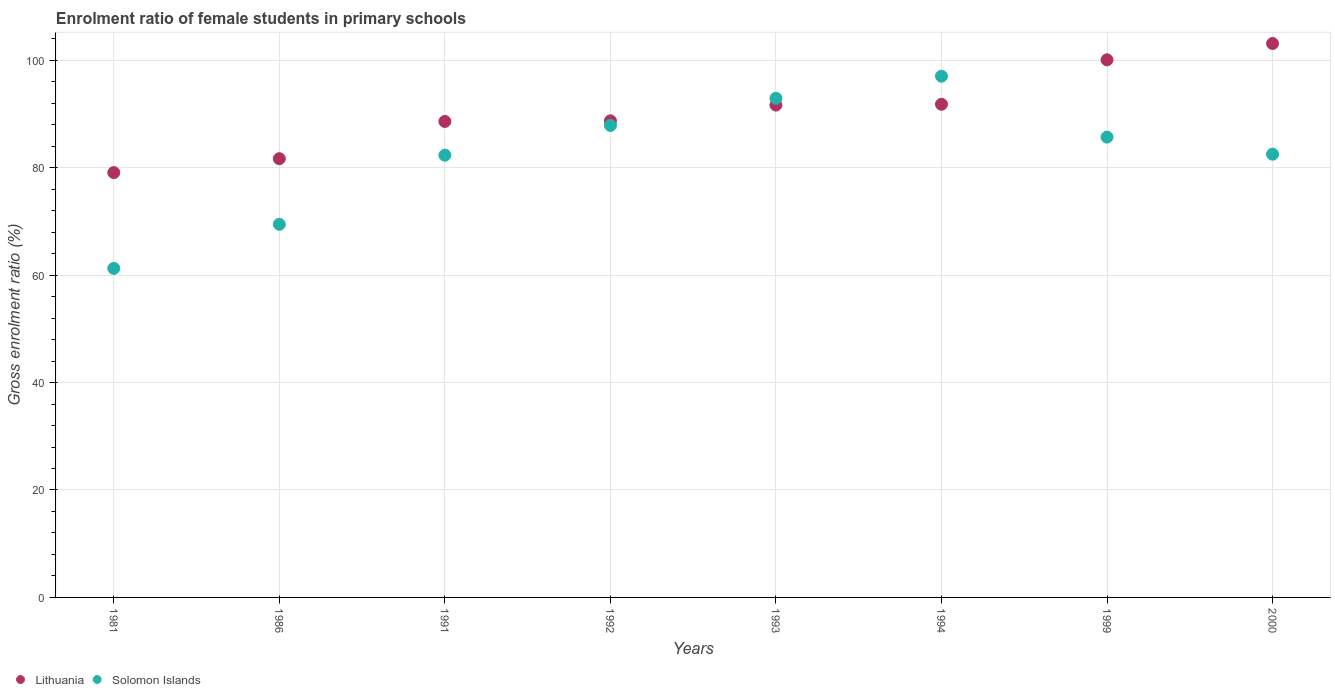Is the number of dotlines equal to the number of legend labels?
Offer a terse response. Yes. What is the enrolment ratio of female students in primary schools in Lithuania in 1991?
Provide a succinct answer. 88.6. Across all years, what is the maximum enrolment ratio of female students in primary schools in Lithuania?
Give a very brief answer. 103.11. Across all years, what is the minimum enrolment ratio of female students in primary schools in Lithuania?
Provide a short and direct response. 79.08. In which year was the enrolment ratio of female students in primary schools in Lithuania maximum?
Ensure brevity in your answer.  2000. In which year was the enrolment ratio of female students in primary schools in Solomon Islands minimum?
Ensure brevity in your answer.  1981. What is the total enrolment ratio of female students in primary schools in Solomon Islands in the graph?
Make the answer very short. 659.01. What is the difference between the enrolment ratio of female students in primary schools in Solomon Islands in 1991 and that in 1994?
Make the answer very short. -14.71. What is the difference between the enrolment ratio of female students in primary schools in Lithuania in 1981 and the enrolment ratio of female students in primary schools in Solomon Islands in 2000?
Offer a very short reply. -3.43. What is the average enrolment ratio of female students in primary schools in Lithuania per year?
Your answer should be very brief. 90.59. In the year 1994, what is the difference between the enrolment ratio of female students in primary schools in Solomon Islands and enrolment ratio of female students in primary schools in Lithuania?
Offer a terse response. 5.23. What is the ratio of the enrolment ratio of female students in primary schools in Solomon Islands in 1991 to that in 2000?
Offer a very short reply. 1. Is the enrolment ratio of female students in primary schools in Solomon Islands in 1986 less than that in 2000?
Provide a short and direct response. Yes. What is the difference between the highest and the second highest enrolment ratio of female students in primary schools in Lithuania?
Provide a succinct answer. 3.04. What is the difference between the highest and the lowest enrolment ratio of female students in primary schools in Lithuania?
Your answer should be compact. 24.03. Does the enrolment ratio of female students in primary schools in Solomon Islands monotonically increase over the years?
Provide a short and direct response. No. How many dotlines are there?
Your answer should be very brief. 2. How many years are there in the graph?
Give a very brief answer. 8. What is the difference between two consecutive major ticks on the Y-axis?
Provide a succinct answer. 20. Does the graph contain any zero values?
Make the answer very short. No. Where does the legend appear in the graph?
Ensure brevity in your answer.  Bottom left. What is the title of the graph?
Offer a very short reply. Enrolment ratio of female students in primary schools. Does "Other small states" appear as one of the legend labels in the graph?
Ensure brevity in your answer.  No. What is the label or title of the X-axis?
Ensure brevity in your answer.  Years. What is the Gross enrolment ratio (%) of Lithuania in 1981?
Make the answer very short. 79.08. What is the Gross enrolment ratio (%) of Solomon Islands in 1981?
Provide a short and direct response. 61.25. What is the Gross enrolment ratio (%) of Lithuania in 1986?
Offer a terse response. 81.67. What is the Gross enrolment ratio (%) in Solomon Islands in 1986?
Offer a very short reply. 69.45. What is the Gross enrolment ratio (%) of Lithuania in 1991?
Offer a terse response. 88.6. What is the Gross enrolment ratio (%) of Solomon Islands in 1991?
Offer a very short reply. 82.32. What is the Gross enrolment ratio (%) in Lithuania in 1992?
Offer a terse response. 88.71. What is the Gross enrolment ratio (%) of Solomon Islands in 1992?
Your answer should be very brief. 87.85. What is the Gross enrolment ratio (%) in Lithuania in 1993?
Provide a succinct answer. 91.65. What is the Gross enrolment ratio (%) in Solomon Islands in 1993?
Offer a very short reply. 92.91. What is the Gross enrolment ratio (%) in Lithuania in 1994?
Your answer should be very brief. 91.8. What is the Gross enrolment ratio (%) in Solomon Islands in 1994?
Offer a terse response. 97.03. What is the Gross enrolment ratio (%) of Lithuania in 1999?
Give a very brief answer. 100.08. What is the Gross enrolment ratio (%) in Solomon Islands in 1999?
Provide a succinct answer. 85.69. What is the Gross enrolment ratio (%) of Lithuania in 2000?
Your answer should be compact. 103.11. What is the Gross enrolment ratio (%) of Solomon Islands in 2000?
Your response must be concise. 82.51. Across all years, what is the maximum Gross enrolment ratio (%) in Lithuania?
Offer a terse response. 103.11. Across all years, what is the maximum Gross enrolment ratio (%) in Solomon Islands?
Offer a terse response. 97.03. Across all years, what is the minimum Gross enrolment ratio (%) of Lithuania?
Provide a succinct answer. 79.08. Across all years, what is the minimum Gross enrolment ratio (%) in Solomon Islands?
Keep it short and to the point. 61.25. What is the total Gross enrolment ratio (%) of Lithuania in the graph?
Give a very brief answer. 724.7. What is the total Gross enrolment ratio (%) in Solomon Islands in the graph?
Keep it short and to the point. 659.01. What is the difference between the Gross enrolment ratio (%) of Lithuania in 1981 and that in 1986?
Keep it short and to the point. -2.59. What is the difference between the Gross enrolment ratio (%) in Solomon Islands in 1981 and that in 1986?
Offer a terse response. -8.21. What is the difference between the Gross enrolment ratio (%) of Lithuania in 1981 and that in 1991?
Your answer should be compact. -9.52. What is the difference between the Gross enrolment ratio (%) in Solomon Islands in 1981 and that in 1991?
Give a very brief answer. -21.07. What is the difference between the Gross enrolment ratio (%) of Lithuania in 1981 and that in 1992?
Keep it short and to the point. -9.63. What is the difference between the Gross enrolment ratio (%) of Solomon Islands in 1981 and that in 1992?
Keep it short and to the point. -26.61. What is the difference between the Gross enrolment ratio (%) of Lithuania in 1981 and that in 1993?
Offer a terse response. -12.57. What is the difference between the Gross enrolment ratio (%) of Solomon Islands in 1981 and that in 1993?
Provide a succinct answer. -31.66. What is the difference between the Gross enrolment ratio (%) in Lithuania in 1981 and that in 1994?
Keep it short and to the point. -12.72. What is the difference between the Gross enrolment ratio (%) in Solomon Islands in 1981 and that in 1994?
Provide a short and direct response. -35.78. What is the difference between the Gross enrolment ratio (%) in Lithuania in 1981 and that in 1999?
Offer a terse response. -21. What is the difference between the Gross enrolment ratio (%) in Solomon Islands in 1981 and that in 1999?
Give a very brief answer. -24.44. What is the difference between the Gross enrolment ratio (%) in Lithuania in 1981 and that in 2000?
Offer a terse response. -24.03. What is the difference between the Gross enrolment ratio (%) in Solomon Islands in 1981 and that in 2000?
Offer a terse response. -21.26. What is the difference between the Gross enrolment ratio (%) in Lithuania in 1986 and that in 1991?
Your answer should be very brief. -6.93. What is the difference between the Gross enrolment ratio (%) in Solomon Islands in 1986 and that in 1991?
Provide a short and direct response. -12.87. What is the difference between the Gross enrolment ratio (%) of Lithuania in 1986 and that in 1992?
Keep it short and to the point. -7.04. What is the difference between the Gross enrolment ratio (%) of Solomon Islands in 1986 and that in 1992?
Your answer should be very brief. -18.4. What is the difference between the Gross enrolment ratio (%) of Lithuania in 1986 and that in 1993?
Provide a short and direct response. -9.97. What is the difference between the Gross enrolment ratio (%) of Solomon Islands in 1986 and that in 1993?
Your answer should be very brief. -23.45. What is the difference between the Gross enrolment ratio (%) of Lithuania in 1986 and that in 1994?
Ensure brevity in your answer.  -10.13. What is the difference between the Gross enrolment ratio (%) in Solomon Islands in 1986 and that in 1994?
Make the answer very short. -27.57. What is the difference between the Gross enrolment ratio (%) of Lithuania in 1986 and that in 1999?
Make the answer very short. -18.4. What is the difference between the Gross enrolment ratio (%) of Solomon Islands in 1986 and that in 1999?
Provide a short and direct response. -16.24. What is the difference between the Gross enrolment ratio (%) in Lithuania in 1986 and that in 2000?
Your answer should be compact. -21.44. What is the difference between the Gross enrolment ratio (%) in Solomon Islands in 1986 and that in 2000?
Ensure brevity in your answer.  -13.06. What is the difference between the Gross enrolment ratio (%) in Lithuania in 1991 and that in 1992?
Your response must be concise. -0.11. What is the difference between the Gross enrolment ratio (%) of Solomon Islands in 1991 and that in 1992?
Ensure brevity in your answer.  -5.53. What is the difference between the Gross enrolment ratio (%) in Lithuania in 1991 and that in 1993?
Offer a very short reply. -3.04. What is the difference between the Gross enrolment ratio (%) of Solomon Islands in 1991 and that in 1993?
Your answer should be very brief. -10.59. What is the difference between the Gross enrolment ratio (%) in Lithuania in 1991 and that in 1994?
Provide a succinct answer. -3.2. What is the difference between the Gross enrolment ratio (%) in Solomon Islands in 1991 and that in 1994?
Keep it short and to the point. -14.71. What is the difference between the Gross enrolment ratio (%) of Lithuania in 1991 and that in 1999?
Keep it short and to the point. -11.48. What is the difference between the Gross enrolment ratio (%) in Solomon Islands in 1991 and that in 1999?
Your answer should be very brief. -3.37. What is the difference between the Gross enrolment ratio (%) of Lithuania in 1991 and that in 2000?
Ensure brevity in your answer.  -14.51. What is the difference between the Gross enrolment ratio (%) of Solomon Islands in 1991 and that in 2000?
Make the answer very short. -0.19. What is the difference between the Gross enrolment ratio (%) in Lithuania in 1992 and that in 1993?
Your answer should be very brief. -2.93. What is the difference between the Gross enrolment ratio (%) of Solomon Islands in 1992 and that in 1993?
Provide a short and direct response. -5.05. What is the difference between the Gross enrolment ratio (%) in Lithuania in 1992 and that in 1994?
Keep it short and to the point. -3.09. What is the difference between the Gross enrolment ratio (%) of Solomon Islands in 1992 and that in 1994?
Offer a terse response. -9.17. What is the difference between the Gross enrolment ratio (%) of Lithuania in 1992 and that in 1999?
Give a very brief answer. -11.36. What is the difference between the Gross enrolment ratio (%) of Solomon Islands in 1992 and that in 1999?
Provide a succinct answer. 2.17. What is the difference between the Gross enrolment ratio (%) in Lithuania in 1992 and that in 2000?
Provide a succinct answer. -14.4. What is the difference between the Gross enrolment ratio (%) in Solomon Islands in 1992 and that in 2000?
Your answer should be compact. 5.34. What is the difference between the Gross enrolment ratio (%) of Lithuania in 1993 and that in 1994?
Offer a terse response. -0.16. What is the difference between the Gross enrolment ratio (%) in Solomon Islands in 1993 and that in 1994?
Provide a short and direct response. -4.12. What is the difference between the Gross enrolment ratio (%) of Lithuania in 1993 and that in 1999?
Provide a short and direct response. -8.43. What is the difference between the Gross enrolment ratio (%) in Solomon Islands in 1993 and that in 1999?
Offer a terse response. 7.22. What is the difference between the Gross enrolment ratio (%) of Lithuania in 1993 and that in 2000?
Your response must be concise. -11.47. What is the difference between the Gross enrolment ratio (%) of Solomon Islands in 1993 and that in 2000?
Keep it short and to the point. 10.4. What is the difference between the Gross enrolment ratio (%) in Lithuania in 1994 and that in 1999?
Your answer should be compact. -8.27. What is the difference between the Gross enrolment ratio (%) of Solomon Islands in 1994 and that in 1999?
Make the answer very short. 11.34. What is the difference between the Gross enrolment ratio (%) in Lithuania in 1994 and that in 2000?
Provide a succinct answer. -11.31. What is the difference between the Gross enrolment ratio (%) in Solomon Islands in 1994 and that in 2000?
Give a very brief answer. 14.52. What is the difference between the Gross enrolment ratio (%) in Lithuania in 1999 and that in 2000?
Your answer should be very brief. -3.04. What is the difference between the Gross enrolment ratio (%) in Solomon Islands in 1999 and that in 2000?
Your response must be concise. 3.18. What is the difference between the Gross enrolment ratio (%) in Lithuania in 1981 and the Gross enrolment ratio (%) in Solomon Islands in 1986?
Give a very brief answer. 9.63. What is the difference between the Gross enrolment ratio (%) in Lithuania in 1981 and the Gross enrolment ratio (%) in Solomon Islands in 1991?
Your answer should be compact. -3.24. What is the difference between the Gross enrolment ratio (%) in Lithuania in 1981 and the Gross enrolment ratio (%) in Solomon Islands in 1992?
Your response must be concise. -8.78. What is the difference between the Gross enrolment ratio (%) in Lithuania in 1981 and the Gross enrolment ratio (%) in Solomon Islands in 1993?
Offer a very short reply. -13.83. What is the difference between the Gross enrolment ratio (%) of Lithuania in 1981 and the Gross enrolment ratio (%) of Solomon Islands in 1994?
Your answer should be very brief. -17.95. What is the difference between the Gross enrolment ratio (%) of Lithuania in 1981 and the Gross enrolment ratio (%) of Solomon Islands in 1999?
Provide a succinct answer. -6.61. What is the difference between the Gross enrolment ratio (%) of Lithuania in 1981 and the Gross enrolment ratio (%) of Solomon Islands in 2000?
Make the answer very short. -3.43. What is the difference between the Gross enrolment ratio (%) of Lithuania in 1986 and the Gross enrolment ratio (%) of Solomon Islands in 1991?
Keep it short and to the point. -0.65. What is the difference between the Gross enrolment ratio (%) of Lithuania in 1986 and the Gross enrolment ratio (%) of Solomon Islands in 1992?
Make the answer very short. -6.18. What is the difference between the Gross enrolment ratio (%) in Lithuania in 1986 and the Gross enrolment ratio (%) in Solomon Islands in 1993?
Keep it short and to the point. -11.24. What is the difference between the Gross enrolment ratio (%) of Lithuania in 1986 and the Gross enrolment ratio (%) of Solomon Islands in 1994?
Your response must be concise. -15.35. What is the difference between the Gross enrolment ratio (%) in Lithuania in 1986 and the Gross enrolment ratio (%) in Solomon Islands in 1999?
Keep it short and to the point. -4.02. What is the difference between the Gross enrolment ratio (%) of Lithuania in 1986 and the Gross enrolment ratio (%) of Solomon Islands in 2000?
Ensure brevity in your answer.  -0.84. What is the difference between the Gross enrolment ratio (%) of Lithuania in 1991 and the Gross enrolment ratio (%) of Solomon Islands in 1992?
Keep it short and to the point. 0.75. What is the difference between the Gross enrolment ratio (%) in Lithuania in 1991 and the Gross enrolment ratio (%) in Solomon Islands in 1993?
Offer a very short reply. -4.31. What is the difference between the Gross enrolment ratio (%) of Lithuania in 1991 and the Gross enrolment ratio (%) of Solomon Islands in 1994?
Offer a very short reply. -8.43. What is the difference between the Gross enrolment ratio (%) in Lithuania in 1991 and the Gross enrolment ratio (%) in Solomon Islands in 1999?
Provide a short and direct response. 2.91. What is the difference between the Gross enrolment ratio (%) of Lithuania in 1991 and the Gross enrolment ratio (%) of Solomon Islands in 2000?
Keep it short and to the point. 6.09. What is the difference between the Gross enrolment ratio (%) in Lithuania in 1992 and the Gross enrolment ratio (%) in Solomon Islands in 1993?
Your answer should be compact. -4.19. What is the difference between the Gross enrolment ratio (%) in Lithuania in 1992 and the Gross enrolment ratio (%) in Solomon Islands in 1994?
Provide a succinct answer. -8.31. What is the difference between the Gross enrolment ratio (%) of Lithuania in 1992 and the Gross enrolment ratio (%) of Solomon Islands in 1999?
Ensure brevity in your answer.  3.03. What is the difference between the Gross enrolment ratio (%) in Lithuania in 1992 and the Gross enrolment ratio (%) in Solomon Islands in 2000?
Keep it short and to the point. 6.2. What is the difference between the Gross enrolment ratio (%) in Lithuania in 1993 and the Gross enrolment ratio (%) in Solomon Islands in 1994?
Ensure brevity in your answer.  -5.38. What is the difference between the Gross enrolment ratio (%) in Lithuania in 1993 and the Gross enrolment ratio (%) in Solomon Islands in 1999?
Your response must be concise. 5.96. What is the difference between the Gross enrolment ratio (%) of Lithuania in 1993 and the Gross enrolment ratio (%) of Solomon Islands in 2000?
Your answer should be very brief. 9.14. What is the difference between the Gross enrolment ratio (%) in Lithuania in 1994 and the Gross enrolment ratio (%) in Solomon Islands in 1999?
Your response must be concise. 6.11. What is the difference between the Gross enrolment ratio (%) in Lithuania in 1994 and the Gross enrolment ratio (%) in Solomon Islands in 2000?
Offer a terse response. 9.29. What is the difference between the Gross enrolment ratio (%) in Lithuania in 1999 and the Gross enrolment ratio (%) in Solomon Islands in 2000?
Provide a succinct answer. 17.57. What is the average Gross enrolment ratio (%) in Lithuania per year?
Make the answer very short. 90.59. What is the average Gross enrolment ratio (%) of Solomon Islands per year?
Your response must be concise. 82.38. In the year 1981, what is the difference between the Gross enrolment ratio (%) of Lithuania and Gross enrolment ratio (%) of Solomon Islands?
Your answer should be compact. 17.83. In the year 1986, what is the difference between the Gross enrolment ratio (%) of Lithuania and Gross enrolment ratio (%) of Solomon Islands?
Offer a very short reply. 12.22. In the year 1991, what is the difference between the Gross enrolment ratio (%) of Lithuania and Gross enrolment ratio (%) of Solomon Islands?
Provide a succinct answer. 6.28. In the year 1992, what is the difference between the Gross enrolment ratio (%) of Lithuania and Gross enrolment ratio (%) of Solomon Islands?
Ensure brevity in your answer.  0.86. In the year 1993, what is the difference between the Gross enrolment ratio (%) of Lithuania and Gross enrolment ratio (%) of Solomon Islands?
Your response must be concise. -1.26. In the year 1994, what is the difference between the Gross enrolment ratio (%) in Lithuania and Gross enrolment ratio (%) in Solomon Islands?
Provide a short and direct response. -5.23. In the year 1999, what is the difference between the Gross enrolment ratio (%) in Lithuania and Gross enrolment ratio (%) in Solomon Islands?
Offer a terse response. 14.39. In the year 2000, what is the difference between the Gross enrolment ratio (%) of Lithuania and Gross enrolment ratio (%) of Solomon Islands?
Keep it short and to the point. 20.6. What is the ratio of the Gross enrolment ratio (%) in Lithuania in 1981 to that in 1986?
Provide a short and direct response. 0.97. What is the ratio of the Gross enrolment ratio (%) of Solomon Islands in 1981 to that in 1986?
Your answer should be very brief. 0.88. What is the ratio of the Gross enrolment ratio (%) of Lithuania in 1981 to that in 1991?
Provide a short and direct response. 0.89. What is the ratio of the Gross enrolment ratio (%) of Solomon Islands in 1981 to that in 1991?
Provide a succinct answer. 0.74. What is the ratio of the Gross enrolment ratio (%) in Lithuania in 1981 to that in 1992?
Your response must be concise. 0.89. What is the ratio of the Gross enrolment ratio (%) in Solomon Islands in 1981 to that in 1992?
Your response must be concise. 0.7. What is the ratio of the Gross enrolment ratio (%) in Lithuania in 1981 to that in 1993?
Provide a short and direct response. 0.86. What is the ratio of the Gross enrolment ratio (%) in Solomon Islands in 1981 to that in 1993?
Offer a terse response. 0.66. What is the ratio of the Gross enrolment ratio (%) in Lithuania in 1981 to that in 1994?
Keep it short and to the point. 0.86. What is the ratio of the Gross enrolment ratio (%) of Solomon Islands in 1981 to that in 1994?
Your response must be concise. 0.63. What is the ratio of the Gross enrolment ratio (%) of Lithuania in 1981 to that in 1999?
Keep it short and to the point. 0.79. What is the ratio of the Gross enrolment ratio (%) in Solomon Islands in 1981 to that in 1999?
Give a very brief answer. 0.71. What is the ratio of the Gross enrolment ratio (%) in Lithuania in 1981 to that in 2000?
Your answer should be compact. 0.77. What is the ratio of the Gross enrolment ratio (%) of Solomon Islands in 1981 to that in 2000?
Give a very brief answer. 0.74. What is the ratio of the Gross enrolment ratio (%) in Lithuania in 1986 to that in 1991?
Provide a succinct answer. 0.92. What is the ratio of the Gross enrolment ratio (%) in Solomon Islands in 1986 to that in 1991?
Offer a very short reply. 0.84. What is the ratio of the Gross enrolment ratio (%) of Lithuania in 1986 to that in 1992?
Your answer should be very brief. 0.92. What is the ratio of the Gross enrolment ratio (%) in Solomon Islands in 1986 to that in 1992?
Give a very brief answer. 0.79. What is the ratio of the Gross enrolment ratio (%) in Lithuania in 1986 to that in 1993?
Ensure brevity in your answer.  0.89. What is the ratio of the Gross enrolment ratio (%) of Solomon Islands in 1986 to that in 1993?
Your response must be concise. 0.75. What is the ratio of the Gross enrolment ratio (%) in Lithuania in 1986 to that in 1994?
Offer a very short reply. 0.89. What is the ratio of the Gross enrolment ratio (%) in Solomon Islands in 1986 to that in 1994?
Give a very brief answer. 0.72. What is the ratio of the Gross enrolment ratio (%) of Lithuania in 1986 to that in 1999?
Your answer should be very brief. 0.82. What is the ratio of the Gross enrolment ratio (%) of Solomon Islands in 1986 to that in 1999?
Provide a short and direct response. 0.81. What is the ratio of the Gross enrolment ratio (%) of Lithuania in 1986 to that in 2000?
Give a very brief answer. 0.79. What is the ratio of the Gross enrolment ratio (%) of Solomon Islands in 1986 to that in 2000?
Your answer should be compact. 0.84. What is the ratio of the Gross enrolment ratio (%) of Lithuania in 1991 to that in 1992?
Provide a short and direct response. 1. What is the ratio of the Gross enrolment ratio (%) in Solomon Islands in 1991 to that in 1992?
Your answer should be very brief. 0.94. What is the ratio of the Gross enrolment ratio (%) of Lithuania in 1991 to that in 1993?
Keep it short and to the point. 0.97. What is the ratio of the Gross enrolment ratio (%) in Solomon Islands in 1991 to that in 1993?
Keep it short and to the point. 0.89. What is the ratio of the Gross enrolment ratio (%) of Lithuania in 1991 to that in 1994?
Your answer should be compact. 0.97. What is the ratio of the Gross enrolment ratio (%) of Solomon Islands in 1991 to that in 1994?
Your answer should be very brief. 0.85. What is the ratio of the Gross enrolment ratio (%) of Lithuania in 1991 to that in 1999?
Keep it short and to the point. 0.89. What is the ratio of the Gross enrolment ratio (%) in Solomon Islands in 1991 to that in 1999?
Keep it short and to the point. 0.96. What is the ratio of the Gross enrolment ratio (%) in Lithuania in 1991 to that in 2000?
Offer a very short reply. 0.86. What is the ratio of the Gross enrolment ratio (%) of Solomon Islands in 1992 to that in 1993?
Your answer should be compact. 0.95. What is the ratio of the Gross enrolment ratio (%) in Lithuania in 1992 to that in 1994?
Your answer should be compact. 0.97. What is the ratio of the Gross enrolment ratio (%) in Solomon Islands in 1992 to that in 1994?
Your answer should be compact. 0.91. What is the ratio of the Gross enrolment ratio (%) of Lithuania in 1992 to that in 1999?
Your response must be concise. 0.89. What is the ratio of the Gross enrolment ratio (%) of Solomon Islands in 1992 to that in 1999?
Keep it short and to the point. 1.03. What is the ratio of the Gross enrolment ratio (%) of Lithuania in 1992 to that in 2000?
Ensure brevity in your answer.  0.86. What is the ratio of the Gross enrolment ratio (%) in Solomon Islands in 1992 to that in 2000?
Offer a very short reply. 1.06. What is the ratio of the Gross enrolment ratio (%) of Lithuania in 1993 to that in 1994?
Your answer should be compact. 1. What is the ratio of the Gross enrolment ratio (%) of Solomon Islands in 1993 to that in 1994?
Provide a succinct answer. 0.96. What is the ratio of the Gross enrolment ratio (%) of Lithuania in 1993 to that in 1999?
Keep it short and to the point. 0.92. What is the ratio of the Gross enrolment ratio (%) in Solomon Islands in 1993 to that in 1999?
Keep it short and to the point. 1.08. What is the ratio of the Gross enrolment ratio (%) in Lithuania in 1993 to that in 2000?
Keep it short and to the point. 0.89. What is the ratio of the Gross enrolment ratio (%) in Solomon Islands in 1993 to that in 2000?
Offer a very short reply. 1.13. What is the ratio of the Gross enrolment ratio (%) of Lithuania in 1994 to that in 1999?
Provide a succinct answer. 0.92. What is the ratio of the Gross enrolment ratio (%) of Solomon Islands in 1994 to that in 1999?
Provide a short and direct response. 1.13. What is the ratio of the Gross enrolment ratio (%) in Lithuania in 1994 to that in 2000?
Your answer should be very brief. 0.89. What is the ratio of the Gross enrolment ratio (%) of Solomon Islands in 1994 to that in 2000?
Your response must be concise. 1.18. What is the ratio of the Gross enrolment ratio (%) of Lithuania in 1999 to that in 2000?
Make the answer very short. 0.97. What is the difference between the highest and the second highest Gross enrolment ratio (%) of Lithuania?
Provide a short and direct response. 3.04. What is the difference between the highest and the second highest Gross enrolment ratio (%) in Solomon Islands?
Your response must be concise. 4.12. What is the difference between the highest and the lowest Gross enrolment ratio (%) of Lithuania?
Ensure brevity in your answer.  24.03. What is the difference between the highest and the lowest Gross enrolment ratio (%) of Solomon Islands?
Ensure brevity in your answer.  35.78. 